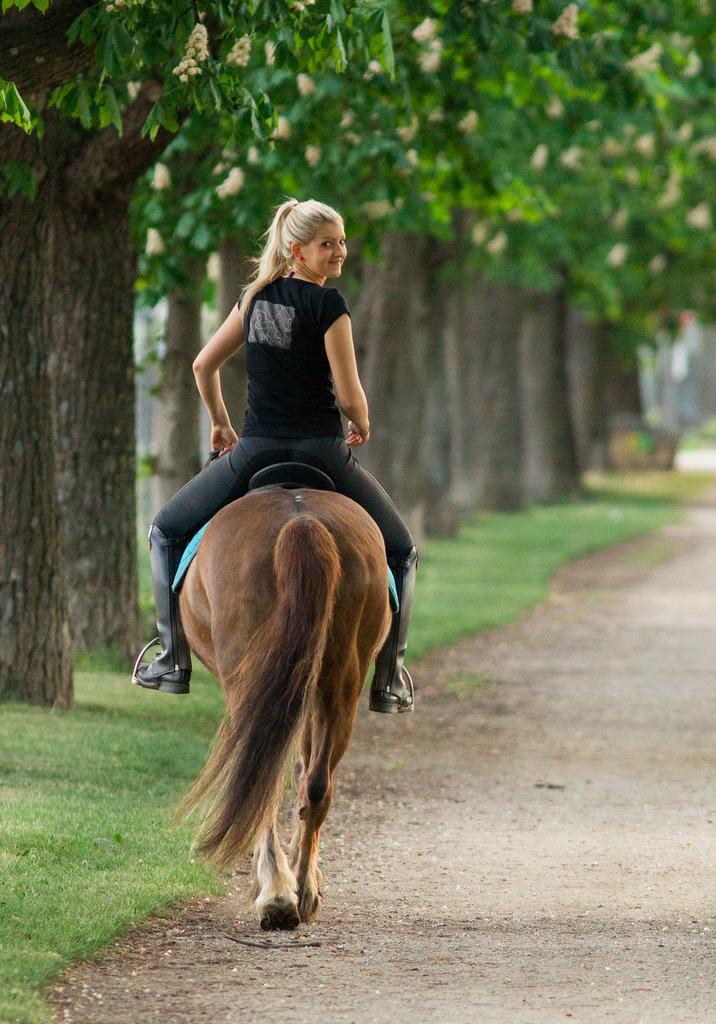Can you describe this image briefly? This Picture describe about the a girl wearing black t- shirt ,pant and shoe is riding the brown horse from the corner of the road, where we can see the trees and grass on the ground. 